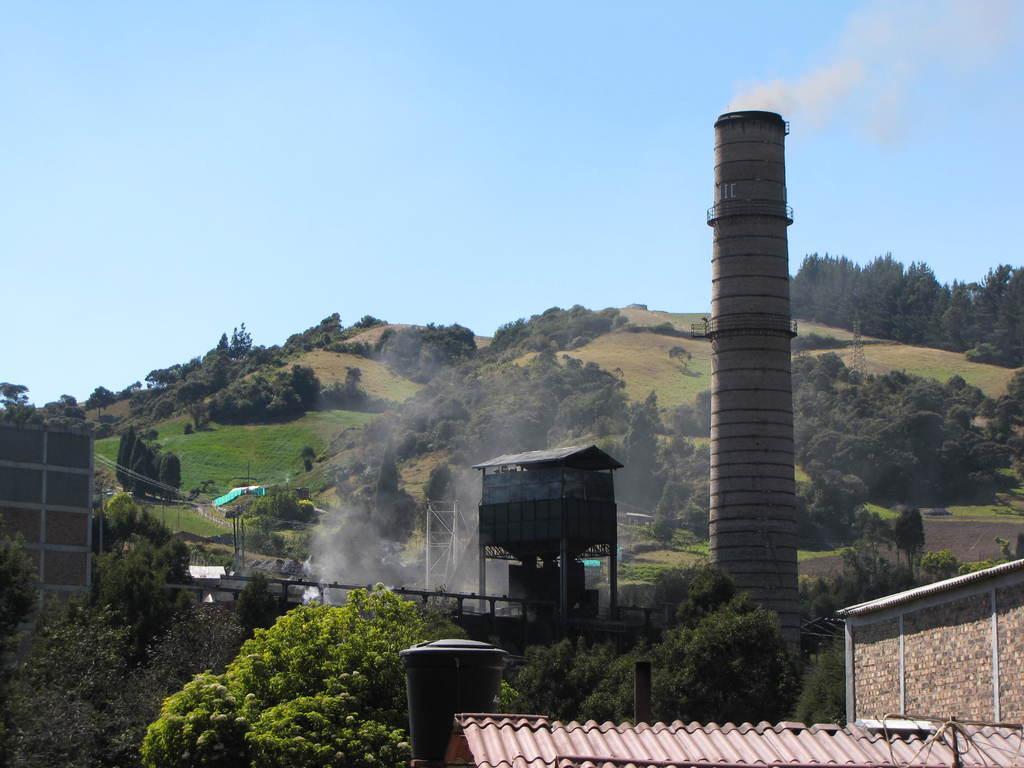Can you describe this image briefly? In this image, we can see some homes, there are some trees, we can see a chimney, there are some mountains, at the top there is a blue sky, 